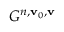Convert formula to latex. <formula><loc_0><loc_0><loc_500><loc_500>G ^ { n , v _ { 0 } , v }</formula> 